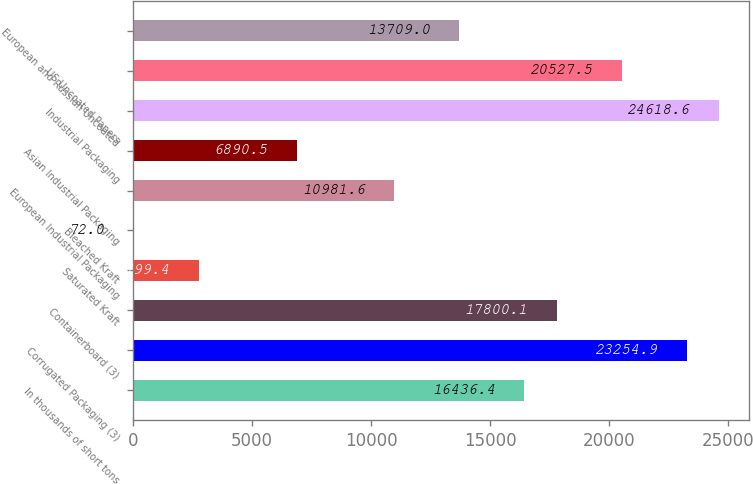<chart> <loc_0><loc_0><loc_500><loc_500><bar_chart><fcel>In thousands of short tons<fcel>Corrugated Packaging (3)<fcel>Containerboard (3)<fcel>Saturated Kraft<fcel>Bleached Kraft<fcel>European Industrial Packaging<fcel>Asian Industrial Packaging<fcel>Industrial Packaging<fcel>US Uncoated Papers<fcel>European and Russian Uncoated<nl><fcel>16436.4<fcel>23254.9<fcel>17800.1<fcel>2799.4<fcel>72<fcel>10981.6<fcel>6890.5<fcel>24618.6<fcel>20527.5<fcel>13709<nl></chart> 